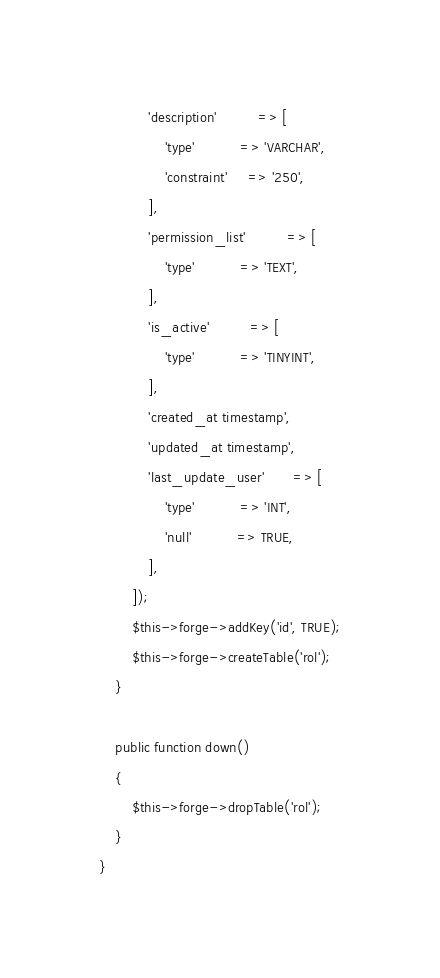<code> <loc_0><loc_0><loc_500><loc_500><_PHP_>			'description'          => [
				'type'           => 'VARCHAR',
				'constraint'     => '250',
			],
			'permission_list'          => [
				'type'           => 'TEXT',
			],
			'is_active'          => [
				'type'           => 'TINYINT',
			],
			'created_at timestamp',
			'updated_at timestamp',
			'last_update_user'       => [
				'type'           => 'INT',
				'null'           => TRUE,
			],
		]);
		$this->forge->addKey('id', TRUE);
		$this->forge->createTable('rol');
	}

	public function down()
	{
		$this->forge->dropTable('rol');
	}
}
</code> 